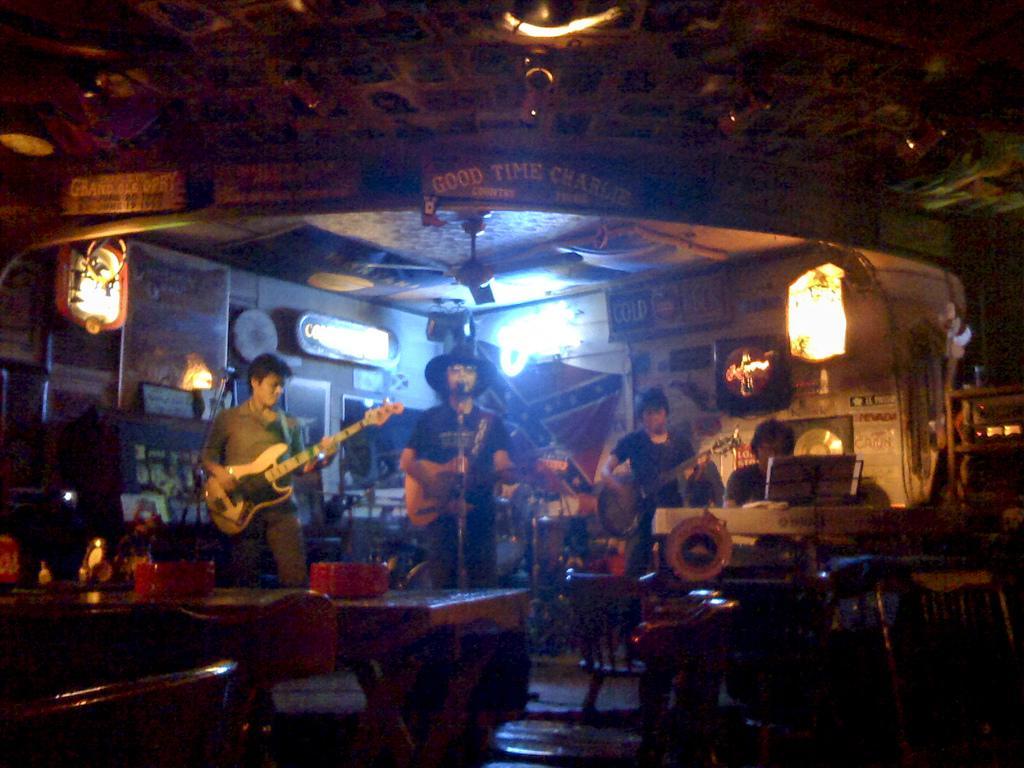How would you summarize this image in a sentence or two? In this image I can see few people are standing and holding guitars. Here I can see a person is sitting. I can also see few tables and chairs. 